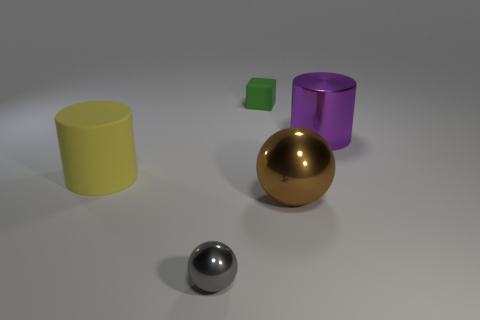Considering the lighting in the image, where do you think the light source is located? The shadows cast by the objects and the highlights on the spheres suggest that there is a light source located above and slightly to the right of the scene, illuminating the objects from that angle. 